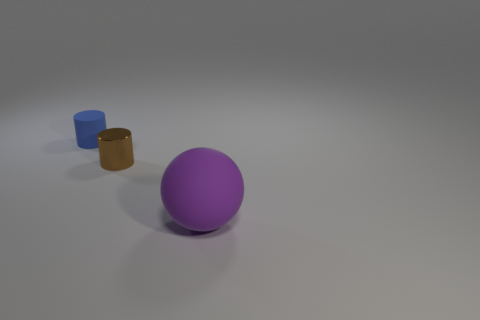How many blue matte things have the same shape as the purple matte thing? 0 